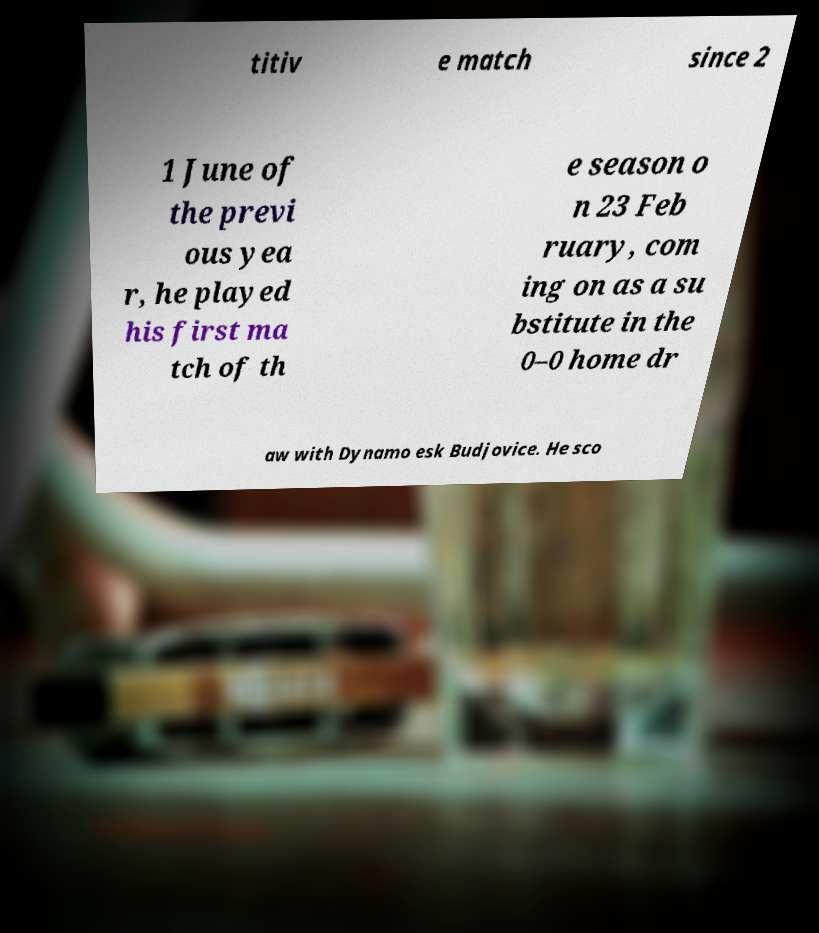What messages or text are displayed in this image? I need them in a readable, typed format. titiv e match since 2 1 June of the previ ous yea r, he played his first ma tch of th e season o n 23 Feb ruary, com ing on as a su bstitute in the 0–0 home dr aw with Dynamo esk Budjovice. He sco 